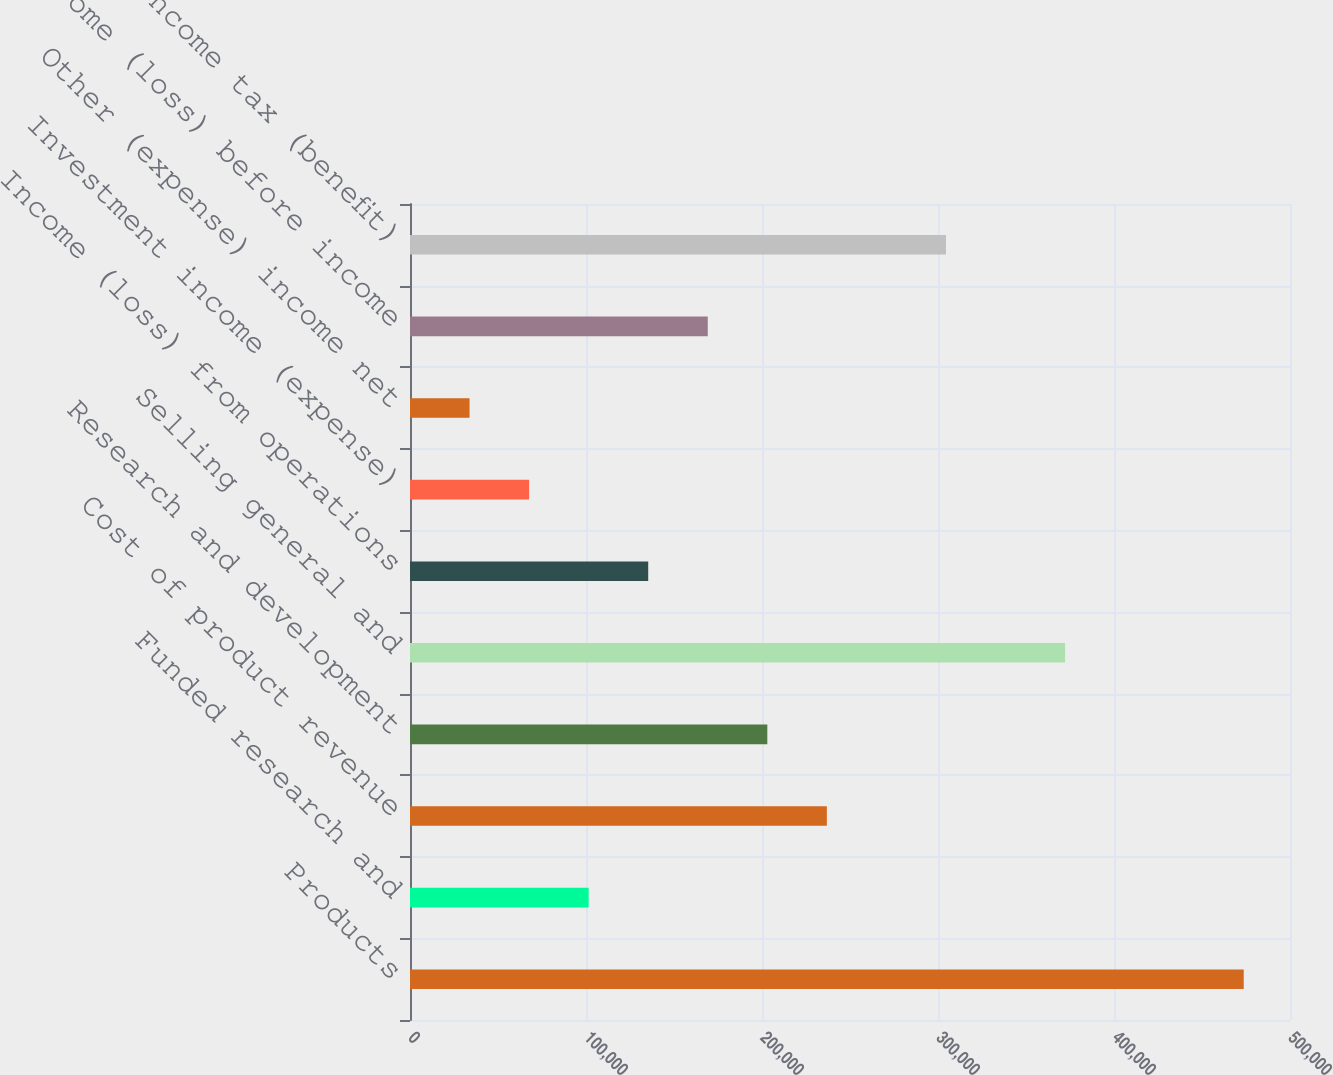Convert chart. <chart><loc_0><loc_0><loc_500><loc_500><bar_chart><fcel>Products<fcel>Funded research and<fcel>Cost of product revenue<fcel>Research and development<fcel>Selling general and<fcel>Income (loss) from operations<fcel>Investment income (expense)<fcel>Other (expense) income net<fcel>Income (loss) before income<fcel>Income tax (benefit)<nl><fcel>473713<fcel>101512<fcel>236858<fcel>203021<fcel>372203<fcel>135348<fcel>67675.6<fcel>33839.2<fcel>169185<fcel>304531<nl></chart> 